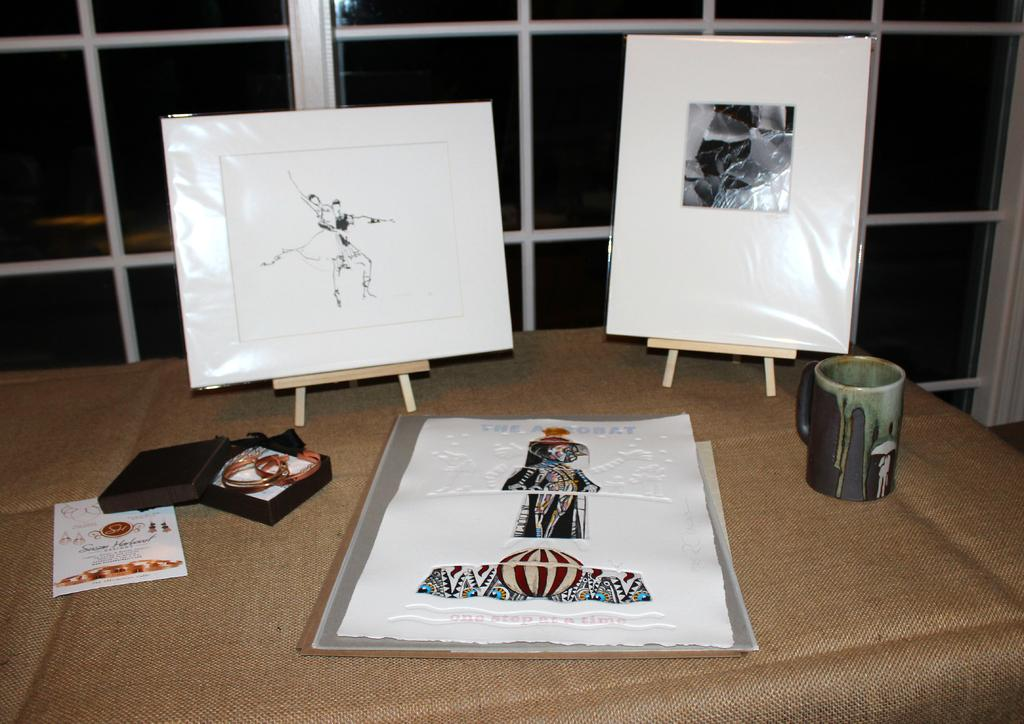What type of items can be seen on the table in the image? Papers, boards, an object inside a box, and a cup are placed on the table in the image. Can you describe the object inside the box? Unfortunately, the object inside the box cannot be identified from the image. What is visible on the backside of the image? There are windows visible on the backside of the image. What type of earth treatment is being performed in the image? There is no earth treatment being performed in the image; it only shows papers, boards, an object inside a box, and a cup on a table. How does the cup turn in the image? The cup does not turn in the image; it is stationary on the table. 